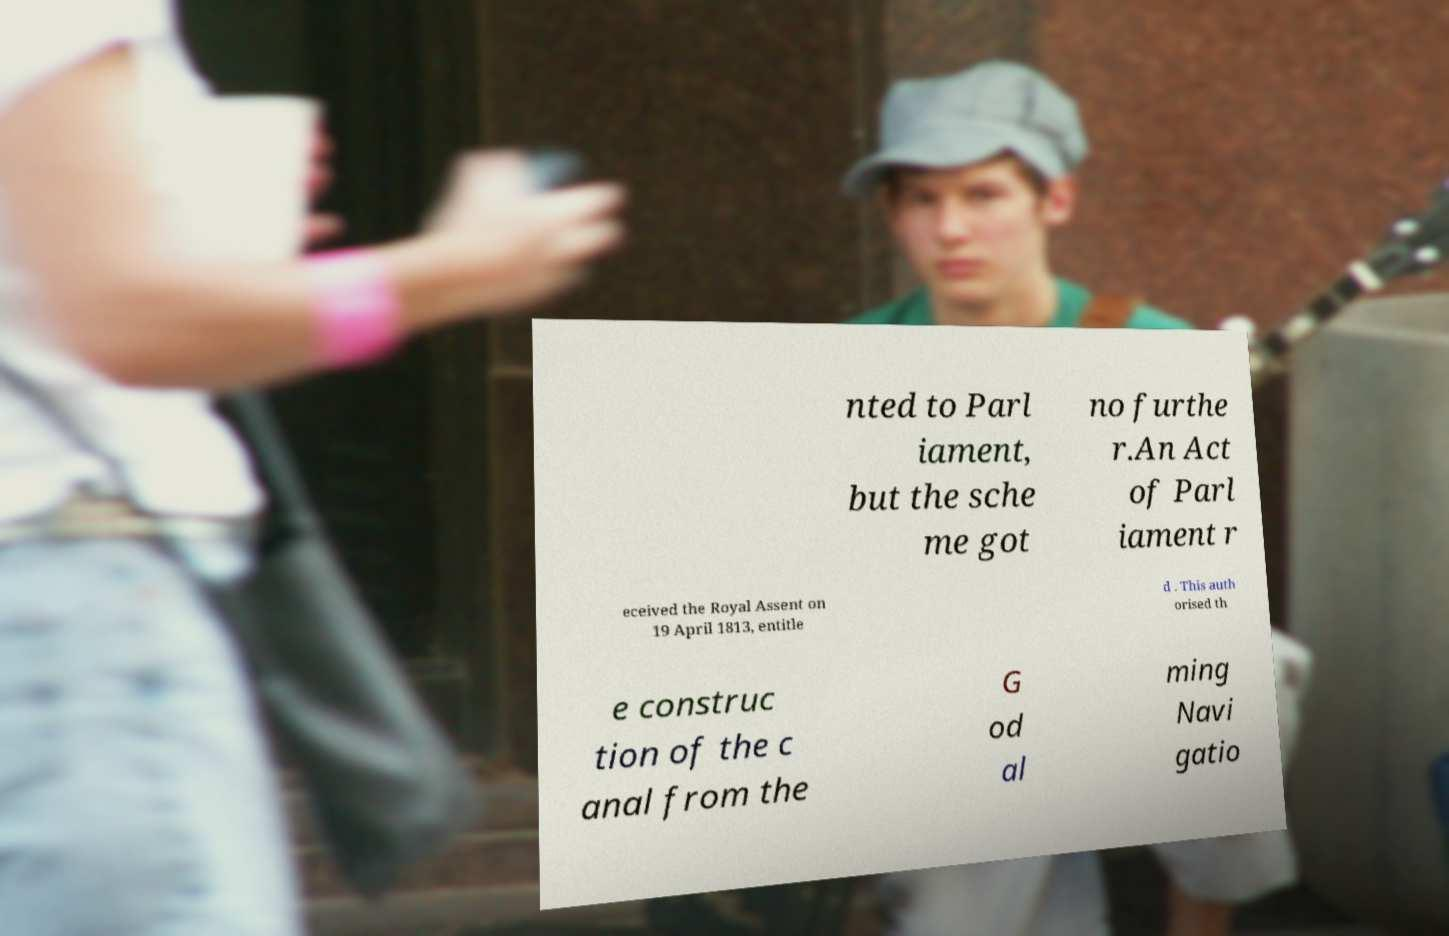Please identify and transcribe the text found in this image. nted to Parl iament, but the sche me got no furthe r.An Act of Parl iament r eceived the Royal Assent on 19 April 1813, entitle d . This auth orised th e construc tion of the c anal from the G od al ming Navi gatio 